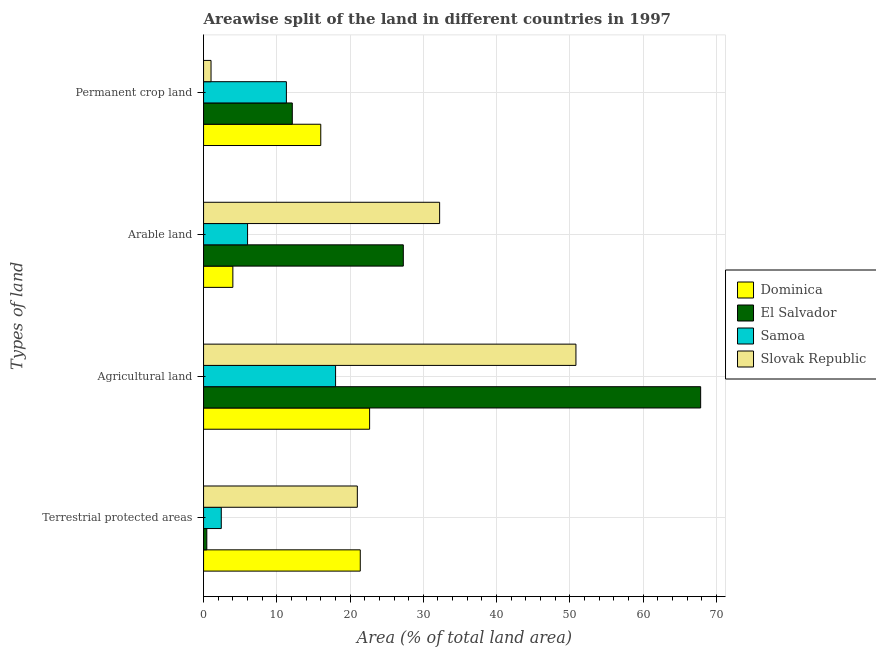Are the number of bars on each tick of the Y-axis equal?
Offer a terse response. Yes. How many bars are there on the 4th tick from the top?
Your answer should be very brief. 4. How many bars are there on the 4th tick from the bottom?
Offer a terse response. 4. What is the label of the 2nd group of bars from the top?
Give a very brief answer. Arable land. What is the percentage of land under terrestrial protection in Samoa?
Make the answer very short. 2.42. Across all countries, what is the maximum percentage of land under terrestrial protection?
Keep it short and to the point. 21.39. Across all countries, what is the minimum percentage of land under terrestrial protection?
Your answer should be compact. 0.44. In which country was the percentage of area under agricultural land maximum?
Keep it short and to the point. El Salvador. In which country was the percentage of land under terrestrial protection minimum?
Offer a very short reply. El Salvador. What is the total percentage of area under agricultural land in the graph?
Your response must be concise. 159.38. What is the difference between the percentage of area under agricultural land in Dominica and that in Samoa?
Keep it short and to the point. 4.65. What is the difference between the percentage of area under agricultural land in El Salvador and the percentage of area under permanent crop land in Dominica?
Keep it short and to the point. 51.86. What is the average percentage of area under permanent crop land per country?
Provide a short and direct response. 10.11. What is the difference between the percentage of area under agricultural land and percentage of area under arable land in Dominica?
Give a very brief answer. 18.67. In how many countries, is the percentage of area under arable land greater than 8 %?
Your answer should be very brief. 2. What is the ratio of the percentage of land under terrestrial protection in El Salvador to that in Samoa?
Your answer should be very brief. 0.18. Is the percentage of area under agricultural land in El Salvador less than that in Slovak Republic?
Provide a short and direct response. No. What is the difference between the highest and the second highest percentage of area under permanent crop land?
Keep it short and to the point. 3.89. What is the difference between the highest and the lowest percentage of area under arable land?
Your response must be concise. 28.22. In how many countries, is the percentage of area under agricultural land greater than the average percentage of area under agricultural land taken over all countries?
Make the answer very short. 2. Is it the case that in every country, the sum of the percentage of area under arable land and percentage of area under permanent crop land is greater than the sum of percentage of land under terrestrial protection and percentage of area under agricultural land?
Your answer should be compact. Yes. What does the 3rd bar from the top in Agricultural land represents?
Provide a succinct answer. El Salvador. What does the 1st bar from the bottom in Permanent crop land represents?
Keep it short and to the point. Dominica. Is it the case that in every country, the sum of the percentage of land under terrestrial protection and percentage of area under agricultural land is greater than the percentage of area under arable land?
Keep it short and to the point. Yes. How many bars are there?
Make the answer very short. 16. How many countries are there in the graph?
Ensure brevity in your answer.  4. What is the difference between two consecutive major ticks on the X-axis?
Provide a short and direct response. 10. Where does the legend appear in the graph?
Give a very brief answer. Center right. How many legend labels are there?
Your response must be concise. 4. How are the legend labels stacked?
Ensure brevity in your answer.  Vertical. What is the title of the graph?
Offer a very short reply. Areawise split of the land in different countries in 1997. What is the label or title of the X-axis?
Keep it short and to the point. Area (% of total land area). What is the label or title of the Y-axis?
Make the answer very short. Types of land. What is the Area (% of total land area) of Dominica in Terrestrial protected areas?
Provide a short and direct response. 21.39. What is the Area (% of total land area) of El Salvador in Terrestrial protected areas?
Make the answer very short. 0.44. What is the Area (% of total land area) in Samoa in Terrestrial protected areas?
Keep it short and to the point. 2.42. What is the Area (% of total land area) in Slovak Republic in Terrestrial protected areas?
Offer a terse response. 20.99. What is the Area (% of total land area) in Dominica in Agricultural land?
Your response must be concise. 22.67. What is the Area (% of total land area) in El Salvador in Agricultural land?
Offer a terse response. 67.86. What is the Area (% of total land area) in Samoa in Agricultural land?
Keep it short and to the point. 18.02. What is the Area (% of total land area) in Slovak Republic in Agricultural land?
Your response must be concise. 50.83. What is the Area (% of total land area) of El Salvador in Arable land?
Offer a very short reply. 27.27. What is the Area (% of total land area) in Samoa in Arable land?
Give a very brief answer. 6.01. What is the Area (% of total land area) in Slovak Republic in Arable land?
Ensure brevity in your answer.  32.22. What is the Area (% of total land area) of El Salvador in Permanent crop land?
Keep it short and to the point. 12.11. What is the Area (% of total land area) of Samoa in Permanent crop land?
Make the answer very short. 11.31. What is the Area (% of total land area) in Slovak Republic in Permanent crop land?
Your response must be concise. 1.02. Across all Types of land, what is the maximum Area (% of total land area) of Dominica?
Provide a succinct answer. 22.67. Across all Types of land, what is the maximum Area (% of total land area) of El Salvador?
Offer a very short reply. 67.86. Across all Types of land, what is the maximum Area (% of total land area) of Samoa?
Provide a succinct answer. 18.02. Across all Types of land, what is the maximum Area (% of total land area) in Slovak Republic?
Provide a short and direct response. 50.83. Across all Types of land, what is the minimum Area (% of total land area) in El Salvador?
Your response must be concise. 0.44. Across all Types of land, what is the minimum Area (% of total land area) of Samoa?
Make the answer very short. 2.42. Across all Types of land, what is the minimum Area (% of total land area) of Slovak Republic?
Your answer should be compact. 1.02. What is the total Area (% of total land area) of Dominica in the graph?
Offer a very short reply. 64.06. What is the total Area (% of total land area) in El Salvador in the graph?
Your response must be concise. 107.68. What is the total Area (% of total land area) in Samoa in the graph?
Your answer should be compact. 37.75. What is the total Area (% of total land area) in Slovak Republic in the graph?
Ensure brevity in your answer.  105.07. What is the difference between the Area (% of total land area) in Dominica in Terrestrial protected areas and that in Agricultural land?
Give a very brief answer. -1.27. What is the difference between the Area (% of total land area) in El Salvador in Terrestrial protected areas and that in Agricultural land?
Provide a succinct answer. -67.41. What is the difference between the Area (% of total land area) in Samoa in Terrestrial protected areas and that in Agricultural land?
Give a very brief answer. -15.6. What is the difference between the Area (% of total land area) in Slovak Republic in Terrestrial protected areas and that in Agricultural land?
Your answer should be compact. -29.84. What is the difference between the Area (% of total land area) of Dominica in Terrestrial protected areas and that in Arable land?
Your answer should be very brief. 17.39. What is the difference between the Area (% of total land area) in El Salvador in Terrestrial protected areas and that in Arable land?
Provide a short and direct response. -26.82. What is the difference between the Area (% of total land area) of Samoa in Terrestrial protected areas and that in Arable land?
Provide a succinct answer. -3.59. What is the difference between the Area (% of total land area) in Slovak Republic in Terrestrial protected areas and that in Arable land?
Offer a very short reply. -11.23. What is the difference between the Area (% of total land area) in Dominica in Terrestrial protected areas and that in Permanent crop land?
Make the answer very short. 5.39. What is the difference between the Area (% of total land area) of El Salvador in Terrestrial protected areas and that in Permanent crop land?
Provide a succinct answer. -11.67. What is the difference between the Area (% of total land area) of Samoa in Terrestrial protected areas and that in Permanent crop land?
Offer a very short reply. -8.89. What is the difference between the Area (% of total land area) in Slovak Republic in Terrestrial protected areas and that in Permanent crop land?
Your response must be concise. 19.97. What is the difference between the Area (% of total land area) in Dominica in Agricultural land and that in Arable land?
Your answer should be compact. 18.67. What is the difference between the Area (% of total land area) of El Salvador in Agricultural land and that in Arable land?
Give a very brief answer. 40.59. What is the difference between the Area (% of total land area) in Samoa in Agricultural land and that in Arable land?
Provide a short and direct response. 12.01. What is the difference between the Area (% of total land area) in Slovak Republic in Agricultural land and that in Arable land?
Offer a very short reply. 18.61. What is the difference between the Area (% of total land area) of Dominica in Agricultural land and that in Permanent crop land?
Your response must be concise. 6.67. What is the difference between the Area (% of total land area) of El Salvador in Agricultural land and that in Permanent crop land?
Your answer should be very brief. 55.74. What is the difference between the Area (% of total land area) of Samoa in Agricultural land and that in Permanent crop land?
Your answer should be compact. 6.71. What is the difference between the Area (% of total land area) in Slovak Republic in Agricultural land and that in Permanent crop land?
Your response must be concise. 49.81. What is the difference between the Area (% of total land area) of Dominica in Arable land and that in Permanent crop land?
Your answer should be very brief. -12. What is the difference between the Area (% of total land area) in El Salvador in Arable land and that in Permanent crop land?
Your response must be concise. 15.15. What is the difference between the Area (% of total land area) of Samoa in Arable land and that in Permanent crop land?
Offer a terse response. -5.3. What is the difference between the Area (% of total land area) in Slovak Republic in Arable land and that in Permanent crop land?
Provide a succinct answer. 31.21. What is the difference between the Area (% of total land area) in Dominica in Terrestrial protected areas and the Area (% of total land area) in El Salvador in Agricultural land?
Ensure brevity in your answer.  -46.47. What is the difference between the Area (% of total land area) in Dominica in Terrestrial protected areas and the Area (% of total land area) in Samoa in Agricultural land?
Ensure brevity in your answer.  3.37. What is the difference between the Area (% of total land area) of Dominica in Terrestrial protected areas and the Area (% of total land area) of Slovak Republic in Agricultural land?
Give a very brief answer. -29.44. What is the difference between the Area (% of total land area) of El Salvador in Terrestrial protected areas and the Area (% of total land area) of Samoa in Agricultural land?
Give a very brief answer. -17.58. What is the difference between the Area (% of total land area) in El Salvador in Terrestrial protected areas and the Area (% of total land area) in Slovak Republic in Agricultural land?
Your response must be concise. -50.39. What is the difference between the Area (% of total land area) in Samoa in Terrestrial protected areas and the Area (% of total land area) in Slovak Republic in Agricultural land?
Your answer should be very brief. -48.41. What is the difference between the Area (% of total land area) in Dominica in Terrestrial protected areas and the Area (% of total land area) in El Salvador in Arable land?
Your answer should be very brief. -5.88. What is the difference between the Area (% of total land area) of Dominica in Terrestrial protected areas and the Area (% of total land area) of Samoa in Arable land?
Your response must be concise. 15.38. What is the difference between the Area (% of total land area) in Dominica in Terrestrial protected areas and the Area (% of total land area) in Slovak Republic in Arable land?
Provide a short and direct response. -10.83. What is the difference between the Area (% of total land area) in El Salvador in Terrestrial protected areas and the Area (% of total land area) in Samoa in Arable land?
Provide a short and direct response. -5.56. What is the difference between the Area (% of total land area) in El Salvador in Terrestrial protected areas and the Area (% of total land area) in Slovak Republic in Arable land?
Provide a short and direct response. -31.78. What is the difference between the Area (% of total land area) in Samoa in Terrestrial protected areas and the Area (% of total land area) in Slovak Republic in Arable land?
Offer a very short reply. -29.81. What is the difference between the Area (% of total land area) in Dominica in Terrestrial protected areas and the Area (% of total land area) in El Salvador in Permanent crop land?
Your answer should be very brief. 9.28. What is the difference between the Area (% of total land area) of Dominica in Terrestrial protected areas and the Area (% of total land area) of Samoa in Permanent crop land?
Your response must be concise. 10.08. What is the difference between the Area (% of total land area) of Dominica in Terrestrial protected areas and the Area (% of total land area) of Slovak Republic in Permanent crop land?
Give a very brief answer. 20.37. What is the difference between the Area (% of total land area) in El Salvador in Terrestrial protected areas and the Area (% of total land area) in Samoa in Permanent crop land?
Offer a terse response. -10.86. What is the difference between the Area (% of total land area) of El Salvador in Terrestrial protected areas and the Area (% of total land area) of Slovak Republic in Permanent crop land?
Provide a succinct answer. -0.57. What is the difference between the Area (% of total land area) in Samoa in Terrestrial protected areas and the Area (% of total land area) in Slovak Republic in Permanent crop land?
Keep it short and to the point. 1.4. What is the difference between the Area (% of total land area) of Dominica in Agricultural land and the Area (% of total land area) of El Salvador in Arable land?
Offer a terse response. -4.6. What is the difference between the Area (% of total land area) of Dominica in Agricultural land and the Area (% of total land area) of Samoa in Arable land?
Offer a very short reply. 16.66. What is the difference between the Area (% of total land area) of Dominica in Agricultural land and the Area (% of total land area) of Slovak Republic in Arable land?
Ensure brevity in your answer.  -9.56. What is the difference between the Area (% of total land area) in El Salvador in Agricultural land and the Area (% of total land area) in Samoa in Arable land?
Provide a short and direct response. 61.85. What is the difference between the Area (% of total land area) in El Salvador in Agricultural land and the Area (% of total land area) in Slovak Republic in Arable land?
Provide a short and direct response. 35.63. What is the difference between the Area (% of total land area) of Samoa in Agricultural land and the Area (% of total land area) of Slovak Republic in Arable land?
Your answer should be compact. -14.2. What is the difference between the Area (% of total land area) in Dominica in Agricultural land and the Area (% of total land area) in El Salvador in Permanent crop land?
Your answer should be compact. 10.55. What is the difference between the Area (% of total land area) in Dominica in Agricultural land and the Area (% of total land area) in Samoa in Permanent crop land?
Make the answer very short. 11.36. What is the difference between the Area (% of total land area) in Dominica in Agricultural land and the Area (% of total land area) in Slovak Republic in Permanent crop land?
Make the answer very short. 21.65. What is the difference between the Area (% of total land area) of El Salvador in Agricultural land and the Area (% of total land area) of Samoa in Permanent crop land?
Offer a terse response. 56.55. What is the difference between the Area (% of total land area) of El Salvador in Agricultural land and the Area (% of total land area) of Slovak Republic in Permanent crop land?
Ensure brevity in your answer.  66.84. What is the difference between the Area (% of total land area) of Samoa in Agricultural land and the Area (% of total land area) of Slovak Republic in Permanent crop land?
Your answer should be very brief. 17. What is the difference between the Area (% of total land area) of Dominica in Arable land and the Area (% of total land area) of El Salvador in Permanent crop land?
Provide a short and direct response. -8.11. What is the difference between the Area (% of total land area) of Dominica in Arable land and the Area (% of total land area) of Samoa in Permanent crop land?
Your response must be concise. -7.31. What is the difference between the Area (% of total land area) of Dominica in Arable land and the Area (% of total land area) of Slovak Republic in Permanent crop land?
Offer a very short reply. 2.98. What is the difference between the Area (% of total land area) of El Salvador in Arable land and the Area (% of total land area) of Samoa in Permanent crop land?
Your answer should be compact. 15.96. What is the difference between the Area (% of total land area) of El Salvador in Arable land and the Area (% of total land area) of Slovak Republic in Permanent crop land?
Keep it short and to the point. 26.25. What is the difference between the Area (% of total land area) of Samoa in Arable land and the Area (% of total land area) of Slovak Republic in Permanent crop land?
Provide a short and direct response. 4.99. What is the average Area (% of total land area) in Dominica per Types of land?
Your answer should be very brief. 16.01. What is the average Area (% of total land area) of El Salvador per Types of land?
Your answer should be compact. 26.92. What is the average Area (% of total land area) in Samoa per Types of land?
Provide a short and direct response. 9.44. What is the average Area (% of total land area) in Slovak Republic per Types of land?
Provide a short and direct response. 26.27. What is the difference between the Area (% of total land area) in Dominica and Area (% of total land area) in El Salvador in Terrestrial protected areas?
Make the answer very short. 20.95. What is the difference between the Area (% of total land area) of Dominica and Area (% of total land area) of Samoa in Terrestrial protected areas?
Keep it short and to the point. 18.97. What is the difference between the Area (% of total land area) of Dominica and Area (% of total land area) of Slovak Republic in Terrestrial protected areas?
Make the answer very short. 0.4. What is the difference between the Area (% of total land area) in El Salvador and Area (% of total land area) in Samoa in Terrestrial protected areas?
Offer a very short reply. -1.97. What is the difference between the Area (% of total land area) in El Salvador and Area (% of total land area) in Slovak Republic in Terrestrial protected areas?
Offer a very short reply. -20.55. What is the difference between the Area (% of total land area) of Samoa and Area (% of total land area) of Slovak Republic in Terrestrial protected areas?
Provide a short and direct response. -18.57. What is the difference between the Area (% of total land area) in Dominica and Area (% of total land area) in El Salvador in Agricultural land?
Your answer should be compact. -45.19. What is the difference between the Area (% of total land area) of Dominica and Area (% of total land area) of Samoa in Agricultural land?
Keep it short and to the point. 4.65. What is the difference between the Area (% of total land area) in Dominica and Area (% of total land area) in Slovak Republic in Agricultural land?
Your response must be concise. -28.16. What is the difference between the Area (% of total land area) of El Salvador and Area (% of total land area) of Samoa in Agricultural land?
Offer a terse response. 49.84. What is the difference between the Area (% of total land area) of El Salvador and Area (% of total land area) of Slovak Republic in Agricultural land?
Offer a very short reply. 17.03. What is the difference between the Area (% of total land area) of Samoa and Area (% of total land area) of Slovak Republic in Agricultural land?
Your answer should be compact. -32.81. What is the difference between the Area (% of total land area) in Dominica and Area (% of total land area) in El Salvador in Arable land?
Your answer should be compact. -23.27. What is the difference between the Area (% of total land area) in Dominica and Area (% of total land area) in Samoa in Arable land?
Your answer should be compact. -2.01. What is the difference between the Area (% of total land area) in Dominica and Area (% of total land area) in Slovak Republic in Arable land?
Give a very brief answer. -28.22. What is the difference between the Area (% of total land area) of El Salvador and Area (% of total land area) of Samoa in Arable land?
Make the answer very short. 21.26. What is the difference between the Area (% of total land area) of El Salvador and Area (% of total land area) of Slovak Republic in Arable land?
Your response must be concise. -4.96. What is the difference between the Area (% of total land area) of Samoa and Area (% of total land area) of Slovak Republic in Arable land?
Offer a terse response. -26.22. What is the difference between the Area (% of total land area) in Dominica and Area (% of total land area) in El Salvador in Permanent crop land?
Your answer should be very brief. 3.89. What is the difference between the Area (% of total land area) in Dominica and Area (% of total land area) in Samoa in Permanent crop land?
Offer a very short reply. 4.69. What is the difference between the Area (% of total land area) in Dominica and Area (% of total land area) in Slovak Republic in Permanent crop land?
Make the answer very short. 14.98. What is the difference between the Area (% of total land area) in El Salvador and Area (% of total land area) in Samoa in Permanent crop land?
Your response must be concise. 0.81. What is the difference between the Area (% of total land area) in El Salvador and Area (% of total land area) in Slovak Republic in Permanent crop land?
Provide a short and direct response. 11.1. What is the difference between the Area (% of total land area) of Samoa and Area (% of total land area) of Slovak Republic in Permanent crop land?
Offer a very short reply. 10.29. What is the ratio of the Area (% of total land area) of Dominica in Terrestrial protected areas to that in Agricultural land?
Your answer should be very brief. 0.94. What is the ratio of the Area (% of total land area) in El Salvador in Terrestrial protected areas to that in Agricultural land?
Provide a short and direct response. 0.01. What is the ratio of the Area (% of total land area) in Samoa in Terrestrial protected areas to that in Agricultural land?
Provide a succinct answer. 0.13. What is the ratio of the Area (% of total land area) of Slovak Republic in Terrestrial protected areas to that in Agricultural land?
Your answer should be very brief. 0.41. What is the ratio of the Area (% of total land area) of Dominica in Terrestrial protected areas to that in Arable land?
Provide a short and direct response. 5.35. What is the ratio of the Area (% of total land area) in El Salvador in Terrestrial protected areas to that in Arable land?
Offer a terse response. 0.02. What is the ratio of the Area (% of total land area) in Samoa in Terrestrial protected areas to that in Arable land?
Provide a short and direct response. 0.4. What is the ratio of the Area (% of total land area) in Slovak Republic in Terrestrial protected areas to that in Arable land?
Your response must be concise. 0.65. What is the ratio of the Area (% of total land area) of Dominica in Terrestrial protected areas to that in Permanent crop land?
Your answer should be very brief. 1.34. What is the ratio of the Area (% of total land area) of El Salvador in Terrestrial protected areas to that in Permanent crop land?
Your response must be concise. 0.04. What is the ratio of the Area (% of total land area) of Samoa in Terrestrial protected areas to that in Permanent crop land?
Make the answer very short. 0.21. What is the ratio of the Area (% of total land area) of Slovak Republic in Terrestrial protected areas to that in Permanent crop land?
Your answer should be compact. 20.61. What is the ratio of the Area (% of total land area) of Dominica in Agricultural land to that in Arable land?
Provide a succinct answer. 5.67. What is the ratio of the Area (% of total land area) of El Salvador in Agricultural land to that in Arable land?
Offer a very short reply. 2.49. What is the ratio of the Area (% of total land area) in Samoa in Agricultural land to that in Arable land?
Provide a short and direct response. 3. What is the ratio of the Area (% of total land area) of Slovak Republic in Agricultural land to that in Arable land?
Give a very brief answer. 1.58. What is the ratio of the Area (% of total land area) in Dominica in Agricultural land to that in Permanent crop land?
Your response must be concise. 1.42. What is the ratio of the Area (% of total land area) of El Salvador in Agricultural land to that in Permanent crop land?
Keep it short and to the point. 5.6. What is the ratio of the Area (% of total land area) in Samoa in Agricultural land to that in Permanent crop land?
Keep it short and to the point. 1.59. What is the ratio of the Area (% of total land area) of Slovak Republic in Agricultural land to that in Permanent crop land?
Provide a short and direct response. 49.9. What is the ratio of the Area (% of total land area) in El Salvador in Arable land to that in Permanent crop land?
Give a very brief answer. 2.25. What is the ratio of the Area (% of total land area) in Samoa in Arable land to that in Permanent crop land?
Provide a succinct answer. 0.53. What is the ratio of the Area (% of total land area) in Slovak Republic in Arable land to that in Permanent crop land?
Give a very brief answer. 31.63. What is the difference between the highest and the second highest Area (% of total land area) of Dominica?
Your response must be concise. 1.27. What is the difference between the highest and the second highest Area (% of total land area) in El Salvador?
Offer a terse response. 40.59. What is the difference between the highest and the second highest Area (% of total land area) of Samoa?
Make the answer very short. 6.71. What is the difference between the highest and the second highest Area (% of total land area) of Slovak Republic?
Your answer should be compact. 18.61. What is the difference between the highest and the lowest Area (% of total land area) of Dominica?
Your answer should be very brief. 18.67. What is the difference between the highest and the lowest Area (% of total land area) in El Salvador?
Make the answer very short. 67.41. What is the difference between the highest and the lowest Area (% of total land area) of Samoa?
Your response must be concise. 15.6. What is the difference between the highest and the lowest Area (% of total land area) of Slovak Republic?
Your answer should be compact. 49.81. 